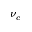Convert formula to latex. <formula><loc_0><loc_0><loc_500><loc_500>\nu _ { c }</formula> 